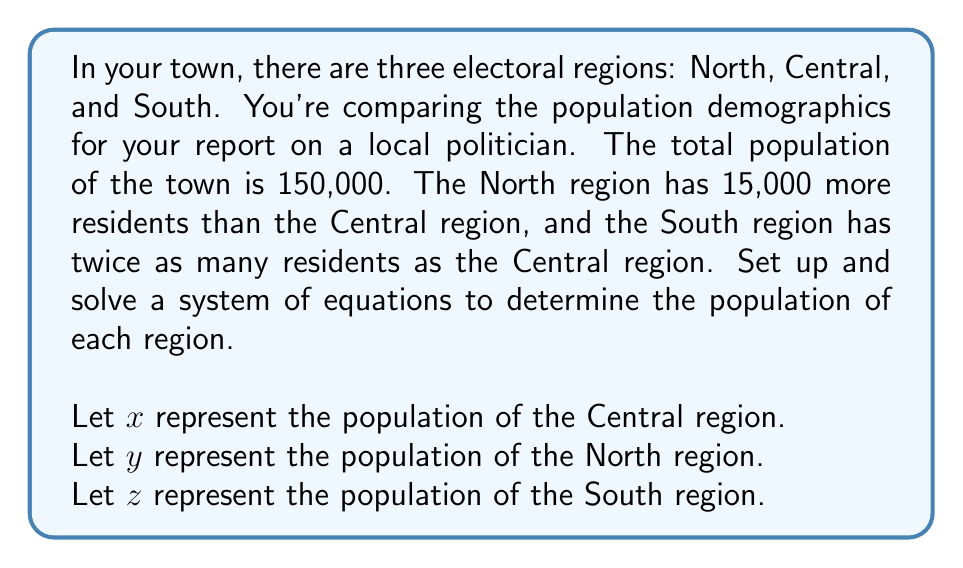Can you solve this math problem? To solve this problem, we need to set up a system of three equations based on the given information:

1. The total population equation:
   $x + y + z = 150,000$

2. The North region has 15,000 more residents than the Central region:
   $y = x + 15,000$

3. The South region has twice as many residents as the Central region:
   $z = 2x$

Now we can solve this system of equations:

Step 1: Substitute the expressions for $y$ and $z$ into the total population equation:
$x + (x + 15,000) + 2x = 150,000$

Step 2: Simplify the equation:
$4x + 15,000 = 150,000$

Step 3: Subtract 15,000 from both sides:
$4x = 135,000$

Step 4: Divide both sides by 4:
$x = 33,750$

Now that we know the population of the Central region, we can calculate the other two:

North region: $y = x + 15,000 = 33,750 + 15,000 = 48,750$
South region: $z = 2x = 2(33,750) = 67,500$

To verify, we can check that the sum of all three regions equals the total population:
$33,750 + 48,750 + 67,500 = 150,000$
Answer: Central region: 33,750
North region: 48,750
South region: 67,500 